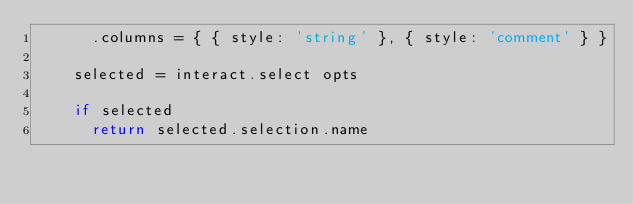<code> <loc_0><loc_0><loc_500><loc_500><_MoonScript_>      .columns = { { style: 'string' }, { style: 'comment' } }

    selected = interact.select opts

    if selected
      return selected.selection.name
</code> 